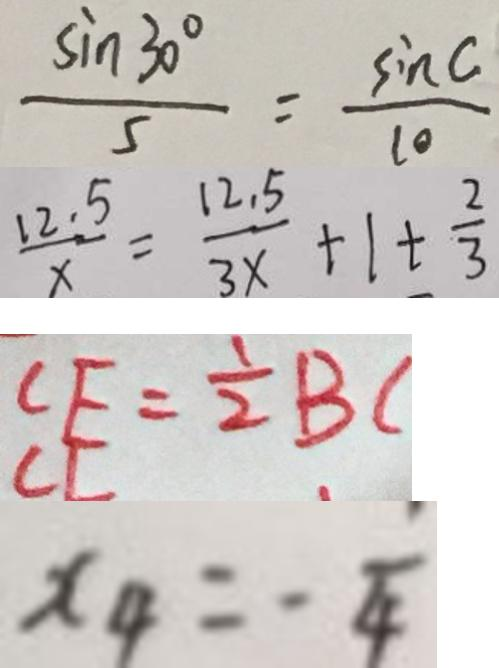<formula> <loc_0><loc_0><loc_500><loc_500>\frac { \sin 3 0 ^ { \circ } } { 5 } = \frac { \sin C } { 1 0 } 
 \frac { 1 2 . 5 } { x } = \frac { 1 2 . 5 } { 3 x } + 1 + \frac { 2 } { 3 } 
 C E = \frac { 1 } { 2 } B C 
 x _ { 4 } = - \frac { 1 } { 4 }</formula> 